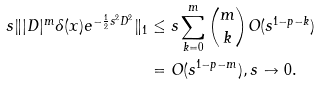Convert formula to latex. <formula><loc_0><loc_0><loc_500><loc_500>s \| | D | ^ { m } \delta ( x ) e ^ { - \frac { 1 } { 2 } s ^ { 2 } D ^ { 2 } } \| _ { 1 } & \leq s \sum _ { k = 0 } ^ { m } \binom { m } { k } O ( s ^ { 1 - p - k } ) \\ & = O ( s ^ { 1 - p - m } ) , s \to 0 .</formula> 